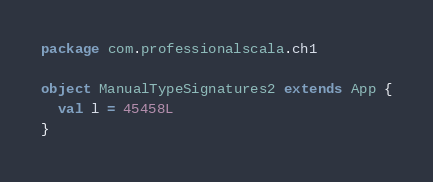Convert code to text. <code><loc_0><loc_0><loc_500><loc_500><_Scala_>package com.professionalscala.ch1

object ManualTypeSignatures2 extends App {
  val l = 45458L
}
</code> 